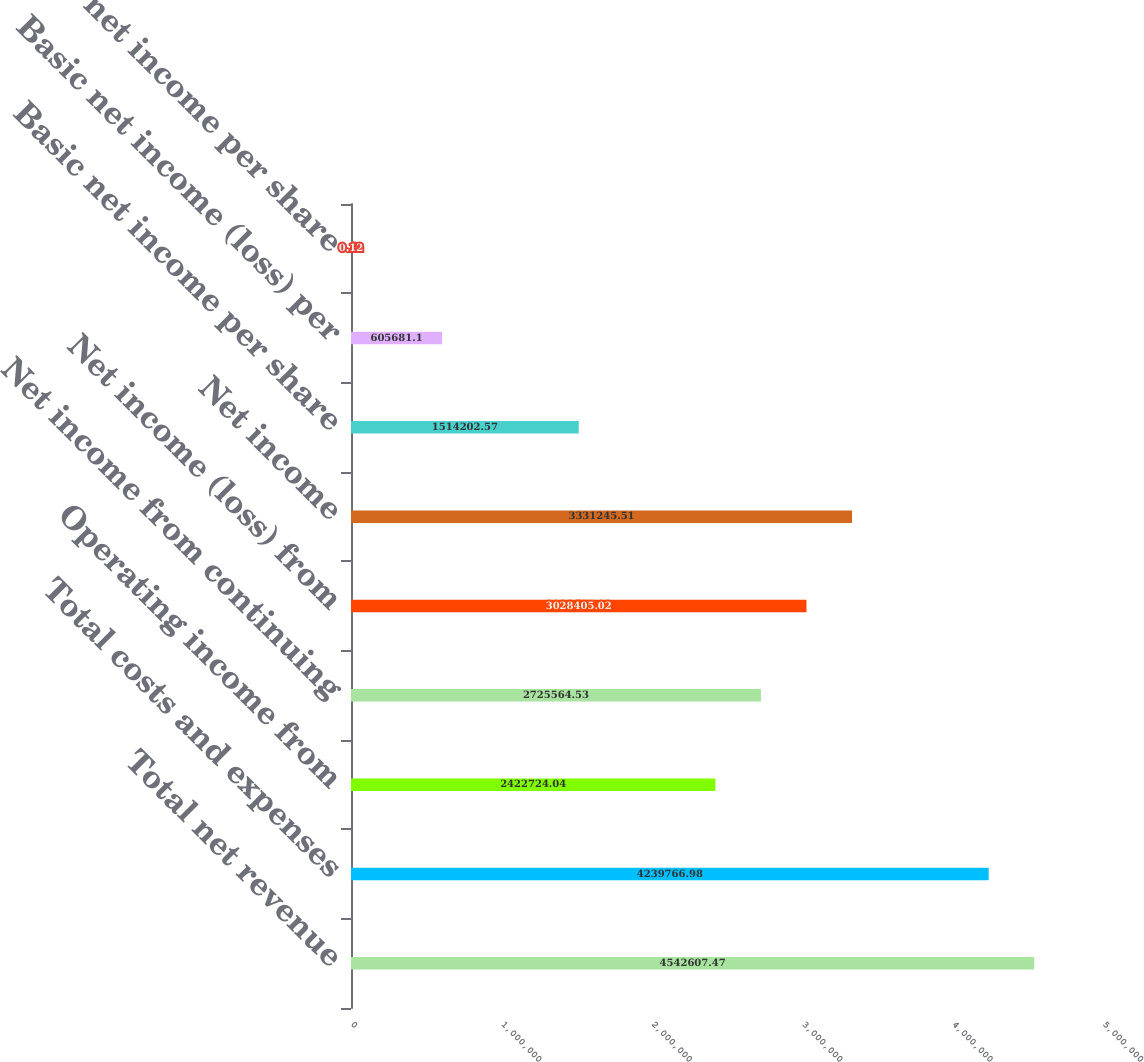Convert chart. <chart><loc_0><loc_0><loc_500><loc_500><bar_chart><fcel>Total net revenue<fcel>Total costs and expenses<fcel>Operating income from<fcel>Net income from continuing<fcel>Net income (loss) from<fcel>Net income<fcel>Basic net income per share<fcel>Basic net income (loss) per<fcel>Diluted net income per share<nl><fcel>4.54261e+06<fcel>4.23977e+06<fcel>2.42272e+06<fcel>2.72556e+06<fcel>3.02841e+06<fcel>3.33125e+06<fcel>1.5142e+06<fcel>605681<fcel>0.12<nl></chart> 